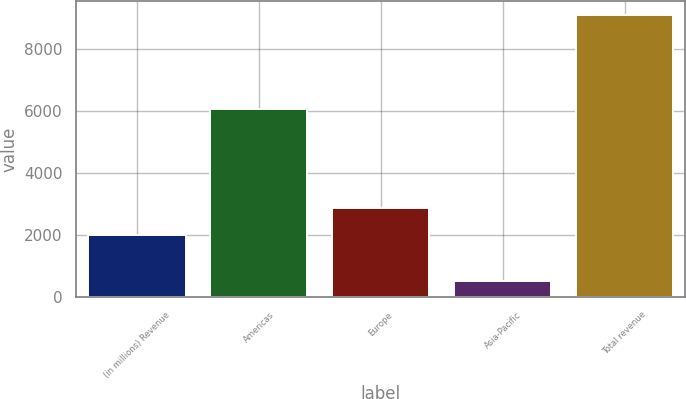<chart> <loc_0><loc_0><loc_500><loc_500><bar_chart><fcel>(in millions) Revenue<fcel>Americas<fcel>Europe<fcel>Asia-Pacific<fcel>Total revenue<nl><fcel>2011<fcel>6064<fcel>2869.1<fcel>500<fcel>9081<nl></chart> 